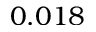Convert formula to latex. <formula><loc_0><loc_0><loc_500><loc_500>0 . 0 1 8</formula> 